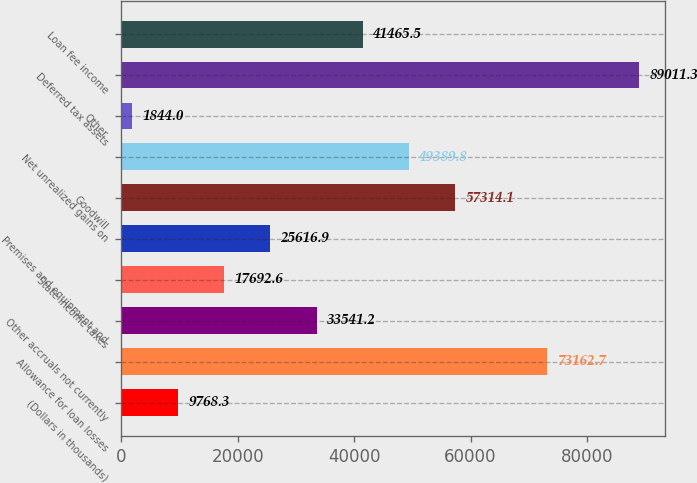<chart> <loc_0><loc_0><loc_500><loc_500><bar_chart><fcel>(Dollars in thousands)<fcel>Allowance for loan losses<fcel>Other accruals not currently<fcel>State income taxes<fcel>Premises and equipment and<fcel>Goodwill<fcel>Net unrealized gains on<fcel>Other<fcel>Deferred tax assets<fcel>Loan fee income<nl><fcel>9768.3<fcel>73162.7<fcel>33541.2<fcel>17692.6<fcel>25616.9<fcel>57314.1<fcel>49389.8<fcel>1844<fcel>89011.3<fcel>41465.5<nl></chart> 